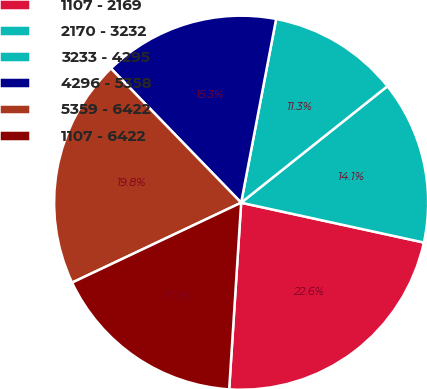<chart> <loc_0><loc_0><loc_500><loc_500><pie_chart><fcel>1107 - 2169<fcel>2170 - 3232<fcel>3233 - 4295<fcel>4296 - 5358<fcel>5359 - 6422<fcel>1107 - 6422<nl><fcel>22.6%<fcel>14.12%<fcel>11.3%<fcel>15.25%<fcel>19.77%<fcel>16.95%<nl></chart> 